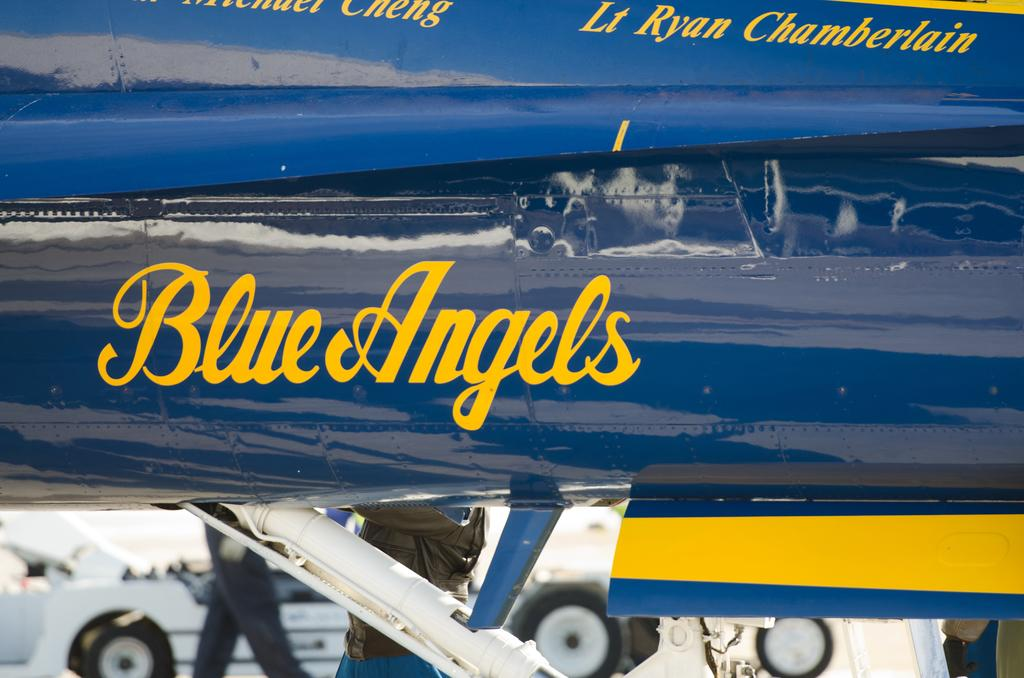<image>
Create a compact narrative representing the image presented. A closeup photo of a blue angels plane, possibly flown by Lt. Ryan Chamberlain. 